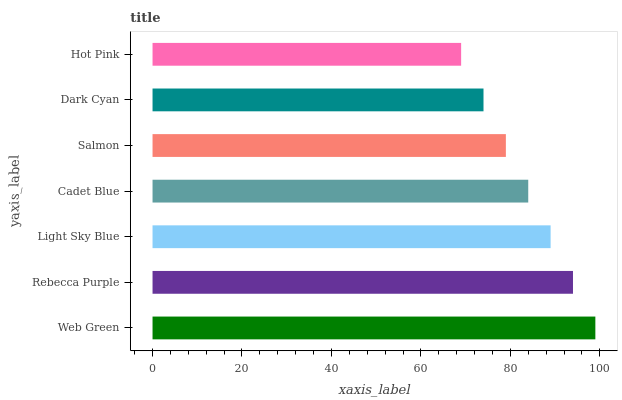Is Hot Pink the minimum?
Answer yes or no. Yes. Is Web Green the maximum?
Answer yes or no. Yes. Is Rebecca Purple the minimum?
Answer yes or no. No. Is Rebecca Purple the maximum?
Answer yes or no. No. Is Web Green greater than Rebecca Purple?
Answer yes or no. Yes. Is Rebecca Purple less than Web Green?
Answer yes or no. Yes. Is Rebecca Purple greater than Web Green?
Answer yes or no. No. Is Web Green less than Rebecca Purple?
Answer yes or no. No. Is Cadet Blue the high median?
Answer yes or no. Yes. Is Cadet Blue the low median?
Answer yes or no. Yes. Is Salmon the high median?
Answer yes or no. No. Is Web Green the low median?
Answer yes or no. No. 